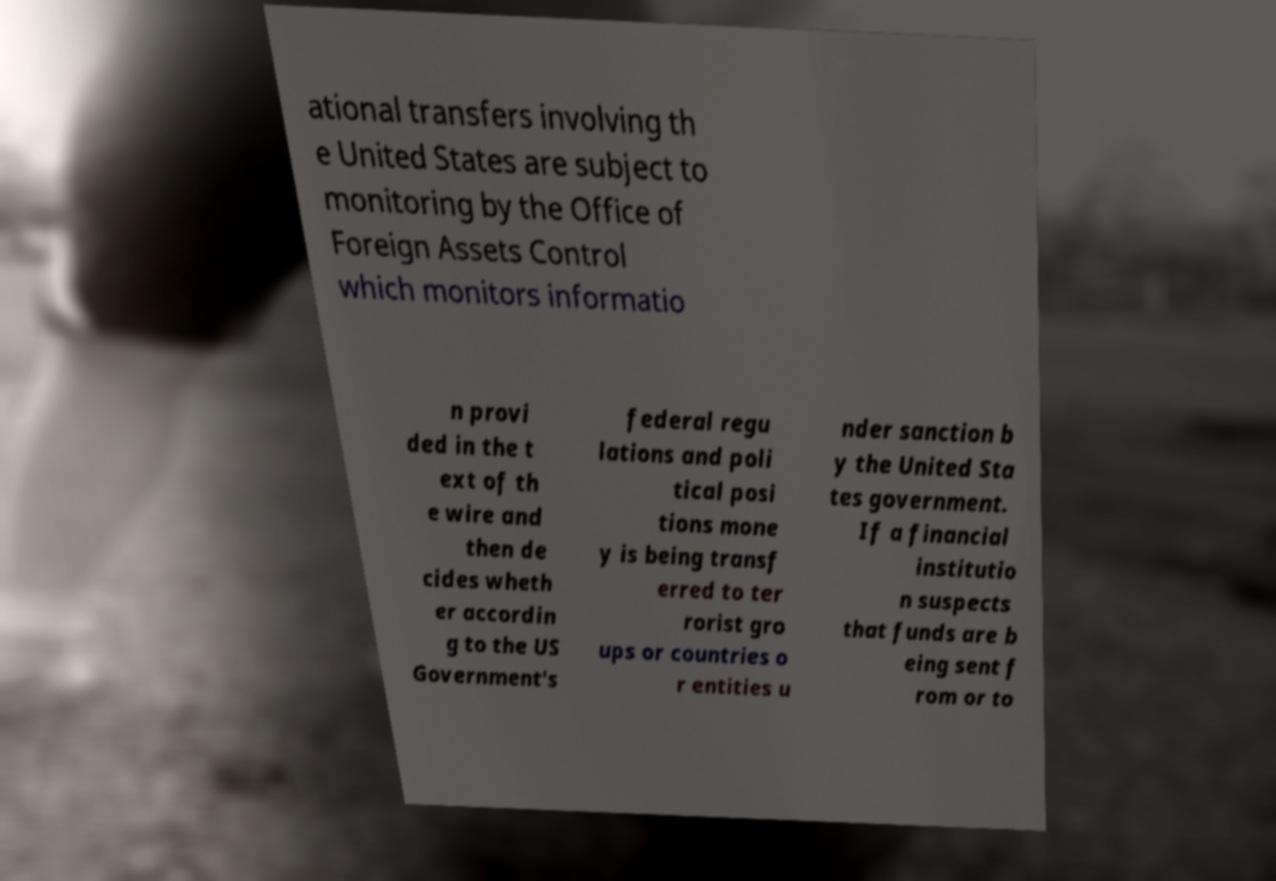Could you assist in decoding the text presented in this image and type it out clearly? ational transfers involving th e United States are subject to monitoring by the Office of Foreign Assets Control which monitors informatio n provi ded in the t ext of th e wire and then de cides wheth er accordin g to the US Government's federal regu lations and poli tical posi tions mone y is being transf erred to ter rorist gro ups or countries o r entities u nder sanction b y the United Sta tes government. If a financial institutio n suspects that funds are b eing sent f rom or to 